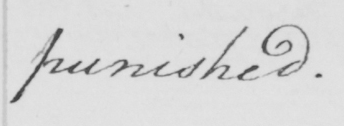Can you read and transcribe this handwriting? punished . 